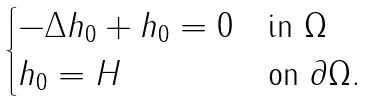Convert formula to latex. <formula><loc_0><loc_0><loc_500><loc_500>\begin{cases} - \Delta h _ { 0 } + h _ { 0 } = 0 & \text {in } \Omega \\ h _ { 0 } = H & \text {on } \partial \Omega . \end{cases}</formula> 